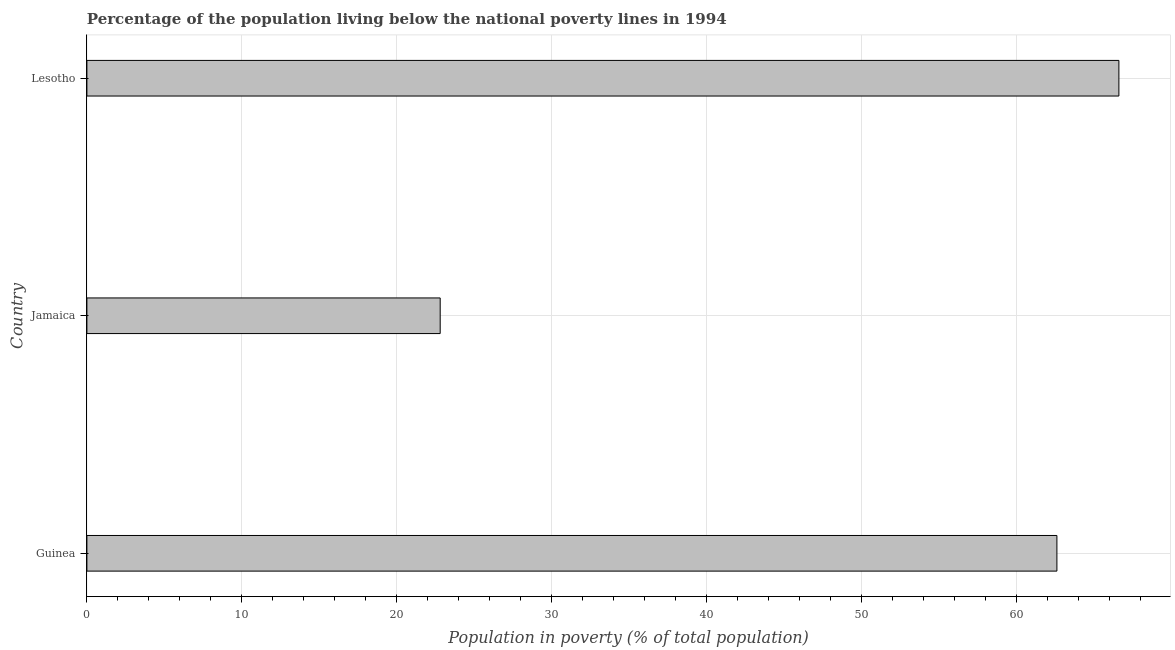Does the graph contain grids?
Offer a very short reply. Yes. What is the title of the graph?
Keep it short and to the point. Percentage of the population living below the national poverty lines in 1994. What is the label or title of the X-axis?
Your answer should be compact. Population in poverty (% of total population). What is the label or title of the Y-axis?
Keep it short and to the point. Country. What is the percentage of population living below poverty line in Guinea?
Ensure brevity in your answer.  62.6. Across all countries, what is the maximum percentage of population living below poverty line?
Make the answer very short. 66.6. Across all countries, what is the minimum percentage of population living below poverty line?
Your response must be concise. 22.8. In which country was the percentage of population living below poverty line maximum?
Offer a very short reply. Lesotho. In which country was the percentage of population living below poverty line minimum?
Your response must be concise. Jamaica. What is the sum of the percentage of population living below poverty line?
Give a very brief answer. 152. What is the average percentage of population living below poverty line per country?
Your answer should be compact. 50.67. What is the median percentage of population living below poverty line?
Ensure brevity in your answer.  62.6. In how many countries, is the percentage of population living below poverty line greater than 14 %?
Keep it short and to the point. 3. What is the ratio of the percentage of population living below poverty line in Jamaica to that in Lesotho?
Offer a terse response. 0.34. Is the difference between the percentage of population living below poverty line in Guinea and Jamaica greater than the difference between any two countries?
Give a very brief answer. No. What is the difference between the highest and the second highest percentage of population living below poverty line?
Make the answer very short. 4. What is the difference between the highest and the lowest percentage of population living below poverty line?
Offer a terse response. 43.8. In how many countries, is the percentage of population living below poverty line greater than the average percentage of population living below poverty line taken over all countries?
Your response must be concise. 2. How many bars are there?
Make the answer very short. 3. What is the difference between two consecutive major ticks on the X-axis?
Offer a terse response. 10. What is the Population in poverty (% of total population) of Guinea?
Your response must be concise. 62.6. What is the Population in poverty (% of total population) of Jamaica?
Offer a terse response. 22.8. What is the Population in poverty (% of total population) in Lesotho?
Your answer should be very brief. 66.6. What is the difference between the Population in poverty (% of total population) in Guinea and Jamaica?
Your answer should be very brief. 39.8. What is the difference between the Population in poverty (% of total population) in Guinea and Lesotho?
Provide a succinct answer. -4. What is the difference between the Population in poverty (% of total population) in Jamaica and Lesotho?
Make the answer very short. -43.8. What is the ratio of the Population in poverty (% of total population) in Guinea to that in Jamaica?
Keep it short and to the point. 2.75. What is the ratio of the Population in poverty (% of total population) in Jamaica to that in Lesotho?
Give a very brief answer. 0.34. 